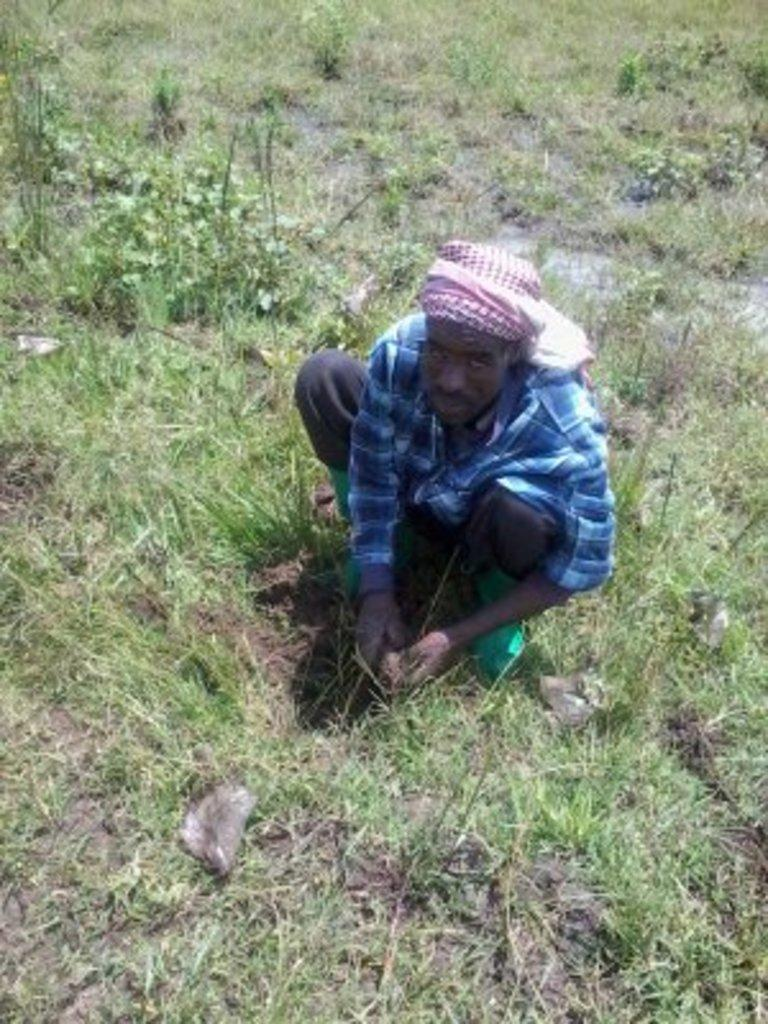Who is in the image? There is a person in the image. What is the person wearing? The person is wearing a blue shirt. What is the person doing in the image? The person is crouching and planting grass. What can be seen on the ground around the person? There is greenery on the ground around the person. Is the person in the image an expert at taking pictures? There is no information about the person's expertise in taking pictures in the image. 